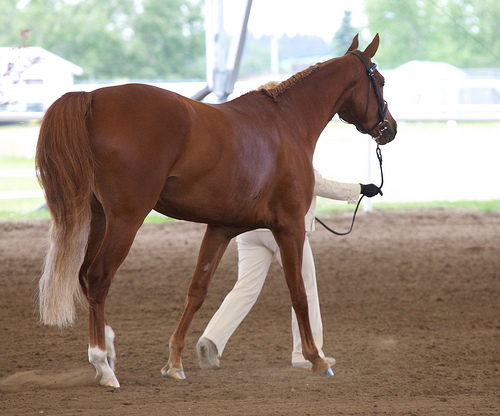<image>
Is the person on the horse? No. The person is not positioned on the horse. They may be near each other, but the person is not supported by or resting on top of the horse. 